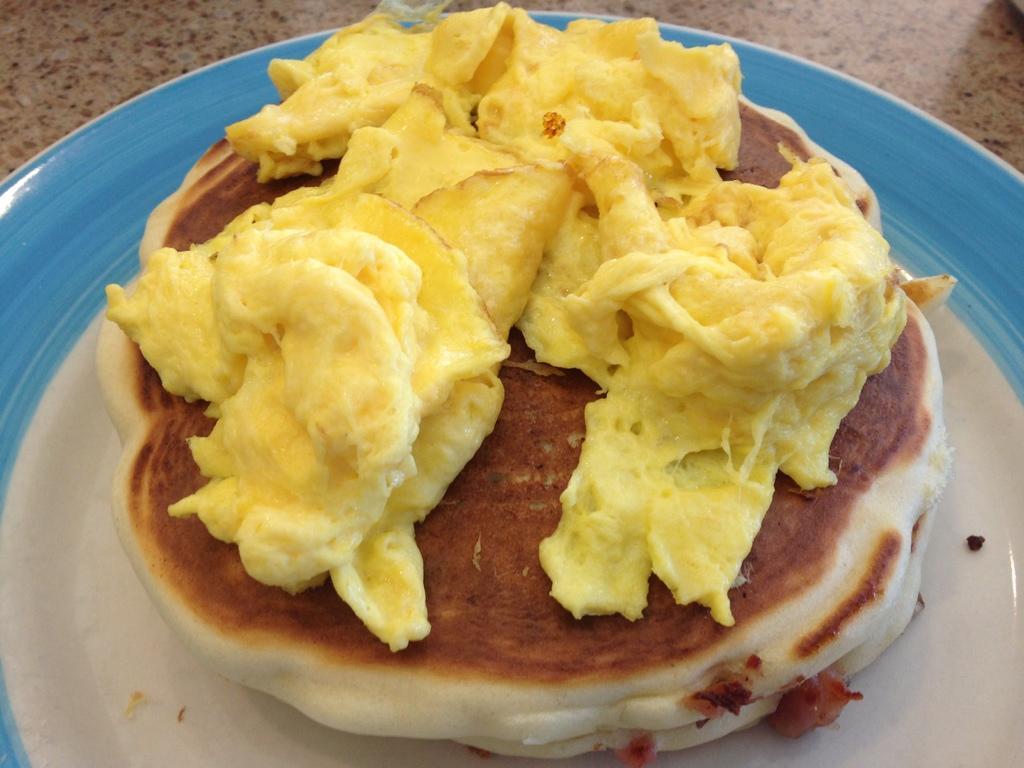Please provide a concise description of this image. In the image there is a plate with bread and cheese above it on a table. 